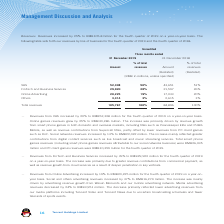According to Tencent's financial document, What was the increase in revenues for the fourth quarter of 2019 on a year-on-year basis? According to the financial document, 25%. The relevant text states: "Revenues. Revenues increased by 25% to RMB105.8 billion for the fourth quarter of 2019 on a year-on-year basis. The..." Also, What was the primary reason for the increase in VAS revenue between the fourth quarter of 2018 and 2019? The increase was primarily driven by revenue growth from smart phone games in both domestic and overseas markets, including titles such as Peacekeeper Elite and PUBG Mobile, as well as revenue contributions from Supercell titles, partly offset by lower revenues from PC client games such as DnF.. The document states: "e games revenues grew by 25% to RMB30,286 million. The increase was primarily driven by revenue growth from smart phone games in both domestic and ove..." Also, What was the primary reason for the increase in FinTech and Business Services revenue between the fourth quarter of 2018 and 2019? The increase was primarily due to greater revenue contributions from commercial payment, as well as revenue growth from cloud services as a result of deeper penetration in key verticals.. The document states: "on a year-on-year basis. The increase was primarily due to greater revenue contributions from commercial payment, as well as revenue growth from cloud..." Also, can you calculate: How much is the change in VAS revenue between the fourth quarter of 2018 and 2019? Based on the calculation: 52,308-43,651, the result is 8657 (in millions). This is based on the information: "VAS 52,308 50% 43,651 51% VAS 52,308 50% 43,651 51%..." The key data points involved are: 43,651, 52,308. Also, can you calculate: How much is the change in FinTech and Business Services revenue between the fourth quarter of 2018 and 2019? Based on the calculation: 29,920-21,597, the result is 8323 (in millions). This is based on the information: "FinTech and Business Services 29,920 28% 21,597 26% FinTech and Business Services 29,920 28% 21,597 26%..." The key data points involved are: 21,597, 29,920. Also, can you calculate: How much is the change in Online Advertising revenue between the fourth quarter of 2018 and 2019? Based on the calculation: 20,225-17,033, the result is 3192 (in millions). This is based on the information: "Online Advertising 20,225 19% 17,033 20% Online Advertising 20,225 19% 17,033 20%..." The key data points involved are: 17,033, 20,225. 